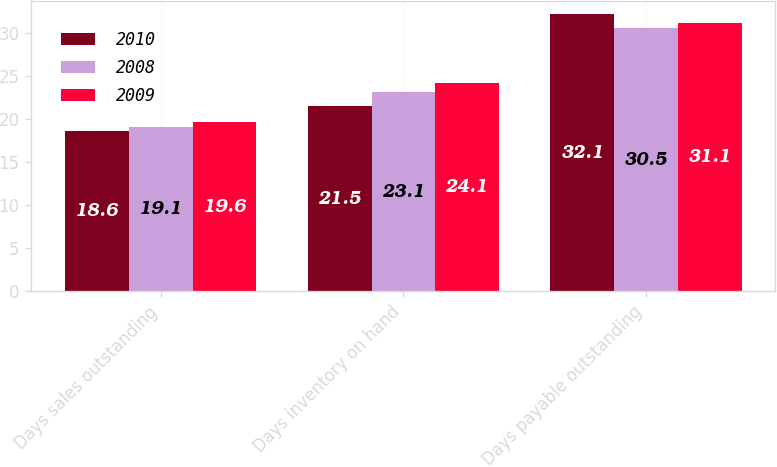<chart> <loc_0><loc_0><loc_500><loc_500><stacked_bar_chart><ecel><fcel>Days sales outstanding<fcel>Days inventory on hand<fcel>Days payable outstanding<nl><fcel>2010<fcel>18.6<fcel>21.5<fcel>32.1<nl><fcel>2008<fcel>19.1<fcel>23.1<fcel>30.5<nl><fcel>2009<fcel>19.6<fcel>24.1<fcel>31.1<nl></chart> 